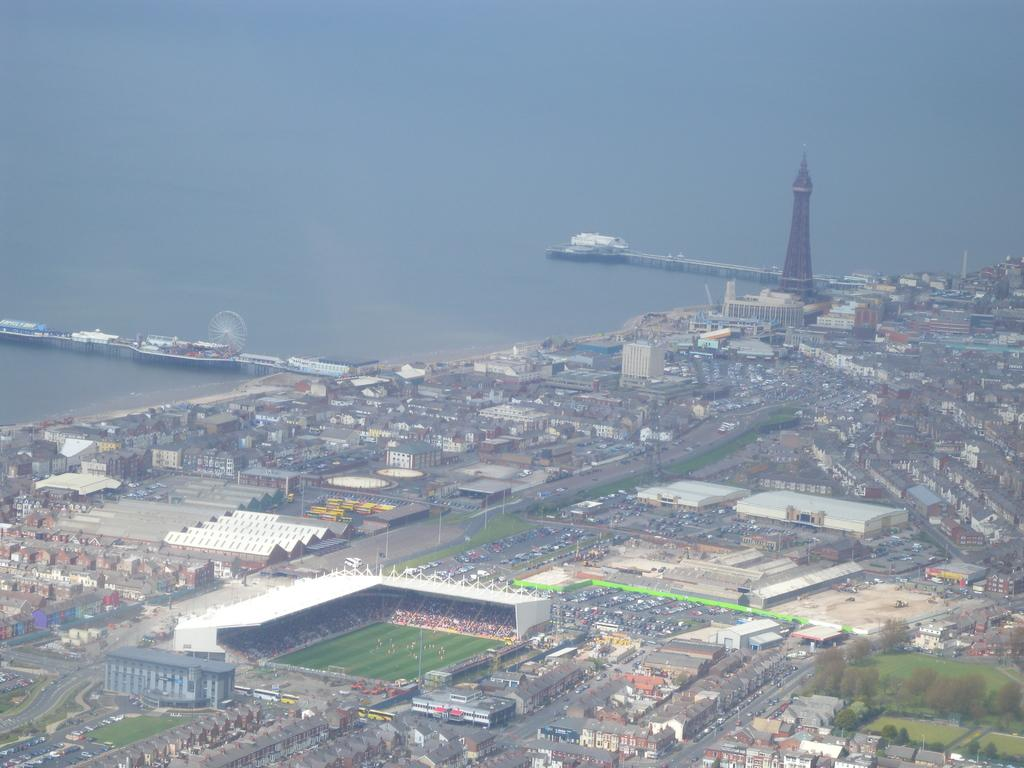What is the primary element in the image? There is water in the image. What structures can be seen in the image? There are bridges, a giant wheel, a tower, buildings, and a stadium visible in the image. What type of transportation is present in the image? Vehicles are present on the road in the image. What natural elements can be seen in the image? Green grass and trees are visible in the image. What additional objects can be seen in the image? There are poles present in the image. What type of committee is meeting in the image? There is no committee meeting in the image; it features a landscape with various structures and natural elements. Can you tell me how many stems are visible in the image? There are no stems present in the image. 